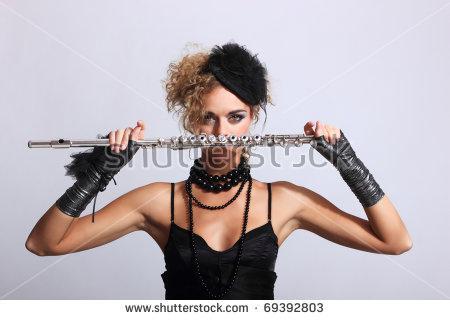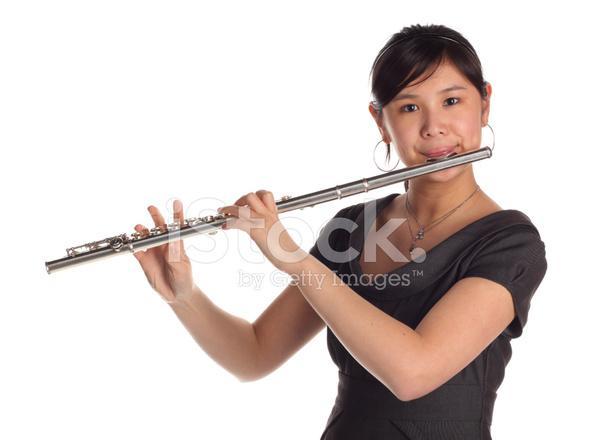The first image is the image on the left, the second image is the image on the right. Assess this claim about the two images: "One image shows one female playing a straight wind instrument, and the other image shows one male in green sleeves playing a wooden wind instrument.". Correct or not? Answer yes or no. No. The first image is the image on the left, the second image is the image on the right. Assess this claim about the two images: "At least one of the people is wearing a green shirt.". Correct or not? Answer yes or no. No. 